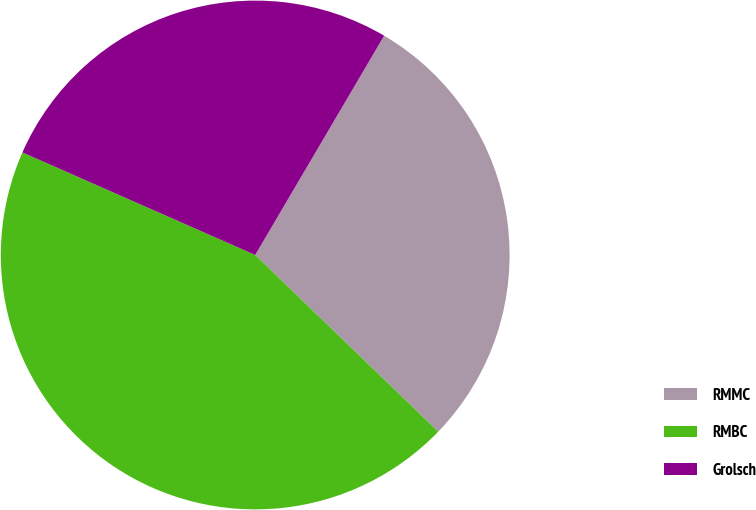Convert chart. <chart><loc_0><loc_0><loc_500><loc_500><pie_chart><fcel>RMMC<fcel>RMBC<fcel>Grolsch<nl><fcel>28.76%<fcel>44.39%<fcel>26.86%<nl></chart> 